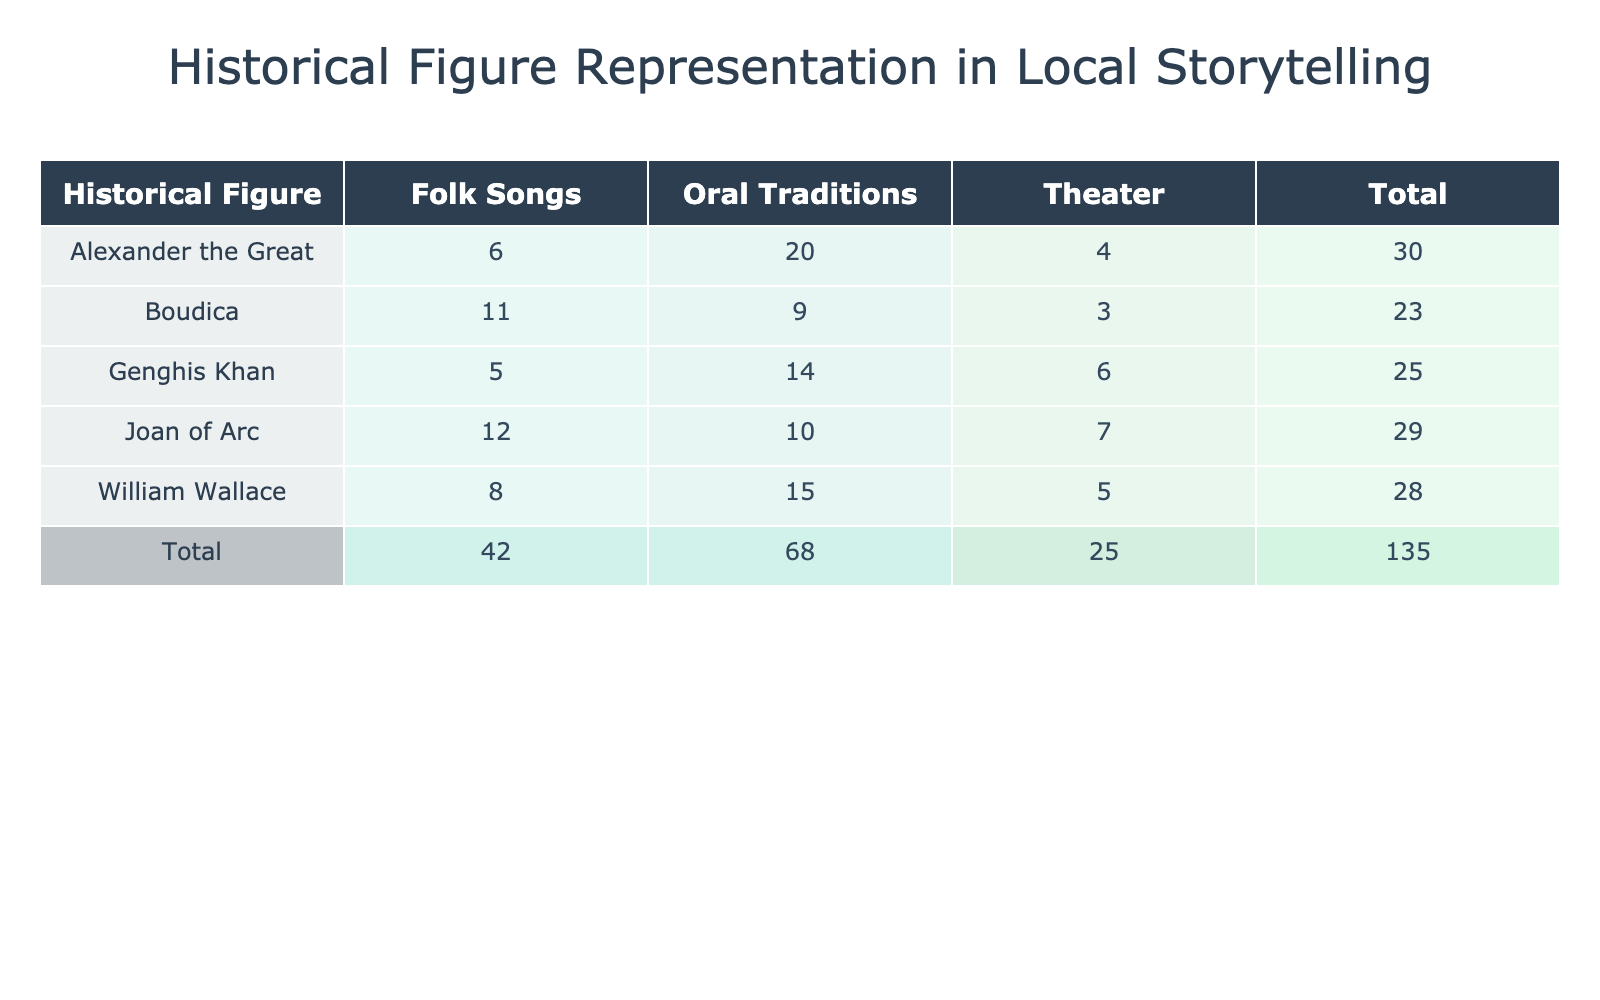What is the representation count for William Wallace in theater? The representation count for William Wallace in theater can be directly found in the row corresponding to William Wallace and the column labeled "Theater." The value is 5.
Answer: 5 Which storytelling medium has the highest total representation for Alexander the Great? To find the highest total representation for Alexander the Great, we examine the values in the row for Alexander the Great. The values are 20 for Oral Traditions, 6 for Folk Songs, and 4 for Theater. The highest among these is 20 for Oral Traditions.
Answer: Oral Traditions What is the total representation count for Joan of Arc across all mediums? We calculate the total representation for Joan of Arc by summing the values from each storytelling medium: 10 (Oral Traditions) + 12 (Folk Songs) + 7 (Theater) = 29.
Answer: 29 Is Genghis Khan represented more often in Folk Songs than in Theater? We compare the representation counts for Genghis Khan in Folk Songs and Theater. The count in Folk Songs is 5, while in Theater it is 6. Since 5 is less than 6, the answer is no.
Answer: No Which historical figure has the lowest total representation count? To find the historical figure with the lowest total representation, we need to sum the representation counts for each figure. After calculating, we find Boudica has a total of 23 (9 + 11 + 3), which is the lowest total compared to the other figures.
Answer: Boudica What is the total representation across all mediums for all historical figures? To find the total representation across all figures, we sum all representation counts in the table: (15 + 8 + 5) + (10 + 12 + 7) + (20 + 6 + 4) + (9 + 11 + 3) + (14 + 5 + 6) = 100.
Answer: 100 Which storytelling medium is least used for Boudica's representation? Looking at Boudica's representation counts, we see 9 for Oral Traditions, 11 for Folk Songs, and 3 for Theater. Theater has the lowest count of 3.
Answer: Theater If we combine the representation counts for all figures in Oral Traditions, what is the total? We sum the counts for all figures in Oral Traditions: 15 (William Wallace) + 10 (Joan of Arc) + 20 (Alexander the Great) + 9 (Boudica) + 14 (Genghis Khan) = 78.
Answer: 78 